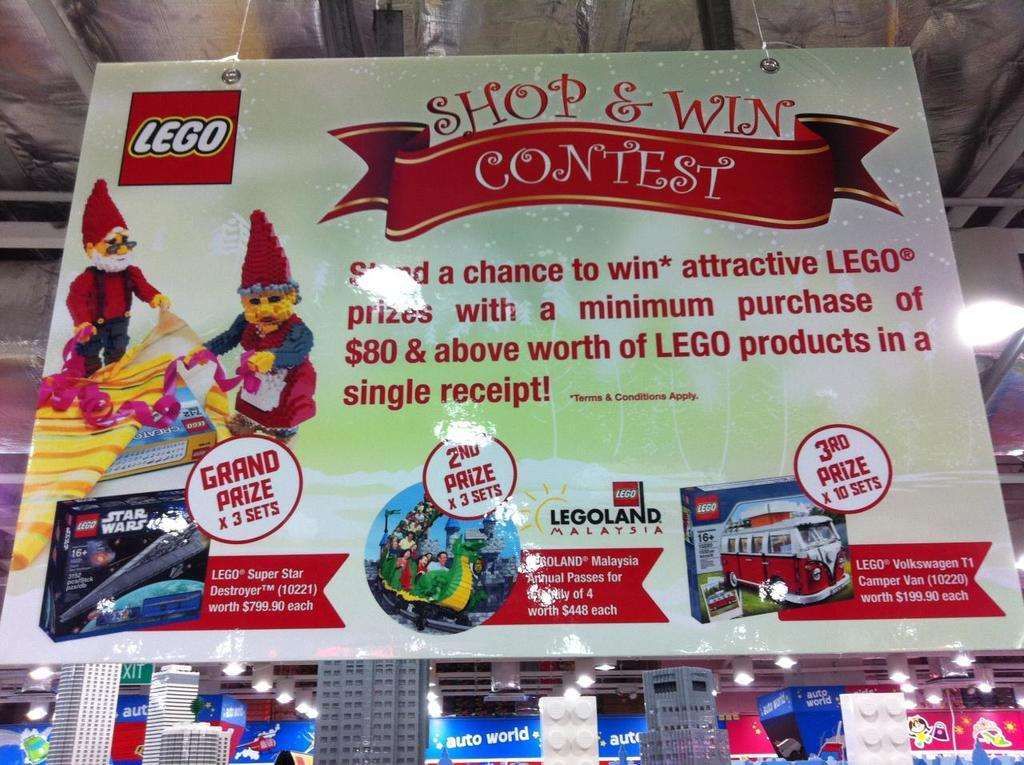What is located in the front of the image? There is a banner with text in the front of the image. What can be seen in the background of the image? There are building models and lights in the background of the image. Are there any other text-related items in the image? Yes, there are boards with text in the background of the image. How much wealth is represented by the pocket in the image? There is no pocket present in the image, so it is not possible to determine the amount of wealth represented. 